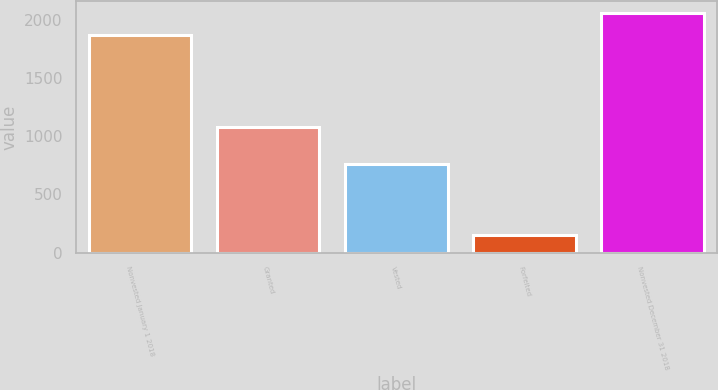<chart> <loc_0><loc_0><loc_500><loc_500><bar_chart><fcel>Nonvested January 1 2018<fcel>Granted<fcel>Vested<fcel>Forfeited<fcel>Nonvested December 31 2018<nl><fcel>1868<fcel>1081<fcel>758<fcel>152<fcel>2056.7<nl></chart> 